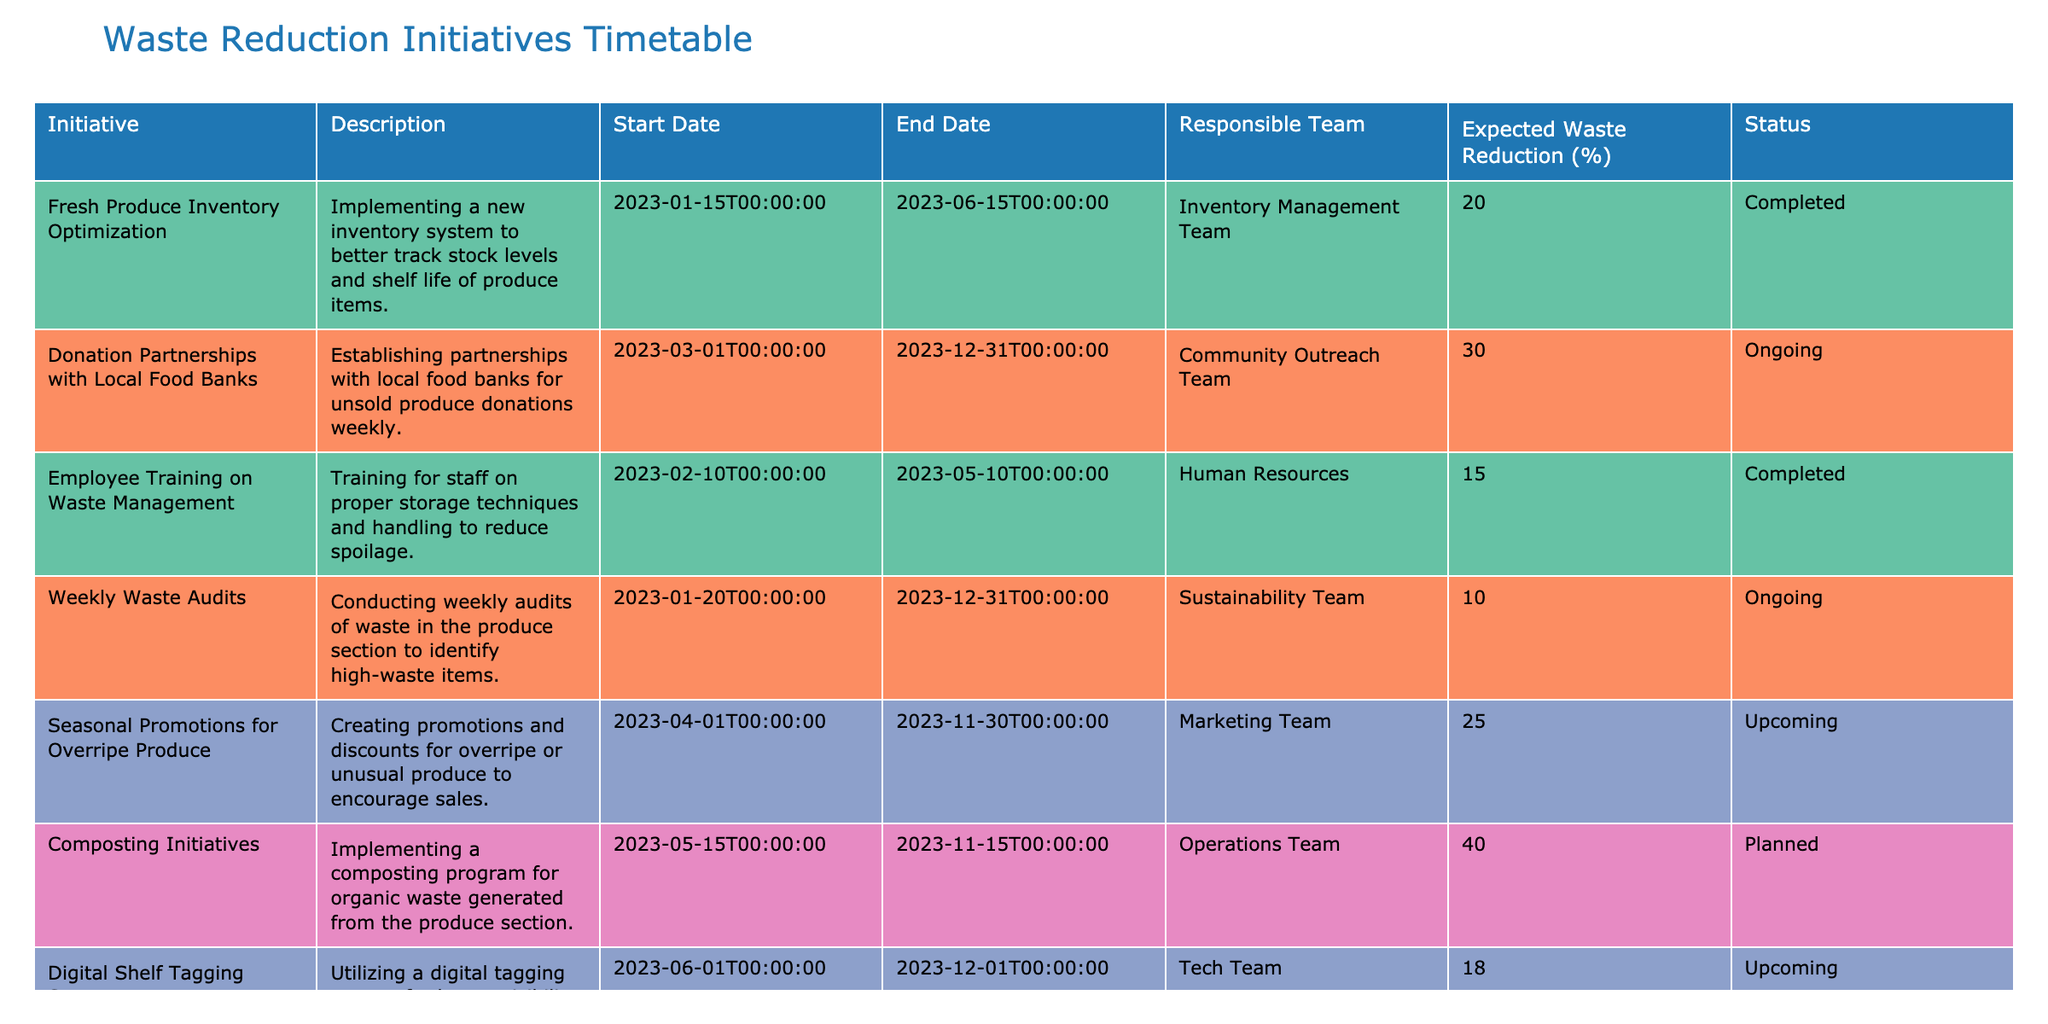What is the expected waste reduction percentage for the "Fresh Produce Inventory Optimization" initiative? The expected waste reduction percentage for this initiative is directly listed in the table under the "Expected Waste Reduction (%)" column. The value associated with "Fresh Produce Inventory Optimization" is 20%.
Answer: 20% Which team is responsible for the "Donation Partnerships with Local Food Banks"? The responsible team is specified in the "Responsible Team" column for the initiative "Donation Partnerships with Local Food Banks". It shows the "Community Outreach Team" as responsible.
Answer: Community Outreach Team How many initiatives are ongoing? To find out how many initiatives are ongoing, we can count the instances in the "Status" column where the value is "Ongoing". There are two initiatives marked as ongoing: "Donation Partnerships with Local Food Banks" and "Weekly Waste Audits".
Answer: 2 What is the median expected waste reduction percentage across all initiatives? To calculate the median expected waste reduction, first list the expected waste reduction percentages: 20, 30, 15, 10, 25, 40, 18. When sorted, the values are 10, 15, 18, 20, 25, 30, 40. Since there are 7 values, the median is the fourth number, which is 20.
Answer: 20 Is there a planned initiative that focuses on composting? Looking at the "Status" column, we can identify any initiative marked as "Planned". The initiative "Composting Initiatives" explicitly shows the status as "Planned", thus confirming the presence of such an initiative.
Answer: Yes Which initiative has the highest expected waste reduction percentage? To determine which initiative has the highest expected waste reduction percentage, we can compare all values listed in that column: 20, 30, 15, 10, 25, 40, and 18. The maximum among these is 40%, related to the "Composting Initiatives".
Answer: Composting Initiatives What are the start and end dates for the "Seasonal Promotions for Overripe Produce"? The table lists the start and end dates directly in their respective columns under the "Seasonal Promotions for Overripe Produce" initiative. The start date is "2023-04-01" and the end date is "2023-11-30".
Answer: 2023-04-01 to 2023-11-30 How many total initiatives are planned or upcoming? To find the total number of planned or upcoming initiatives, we count the instances of "Planned" and "Upcoming" in the "Status" column. The initiatives "Composting Initiatives" is planned, and "Seasonal Promotions for Overripe Produce" and "Digital Shelf Tagging System" are marked upcoming, totaling three initiatives.
Answer: 3 